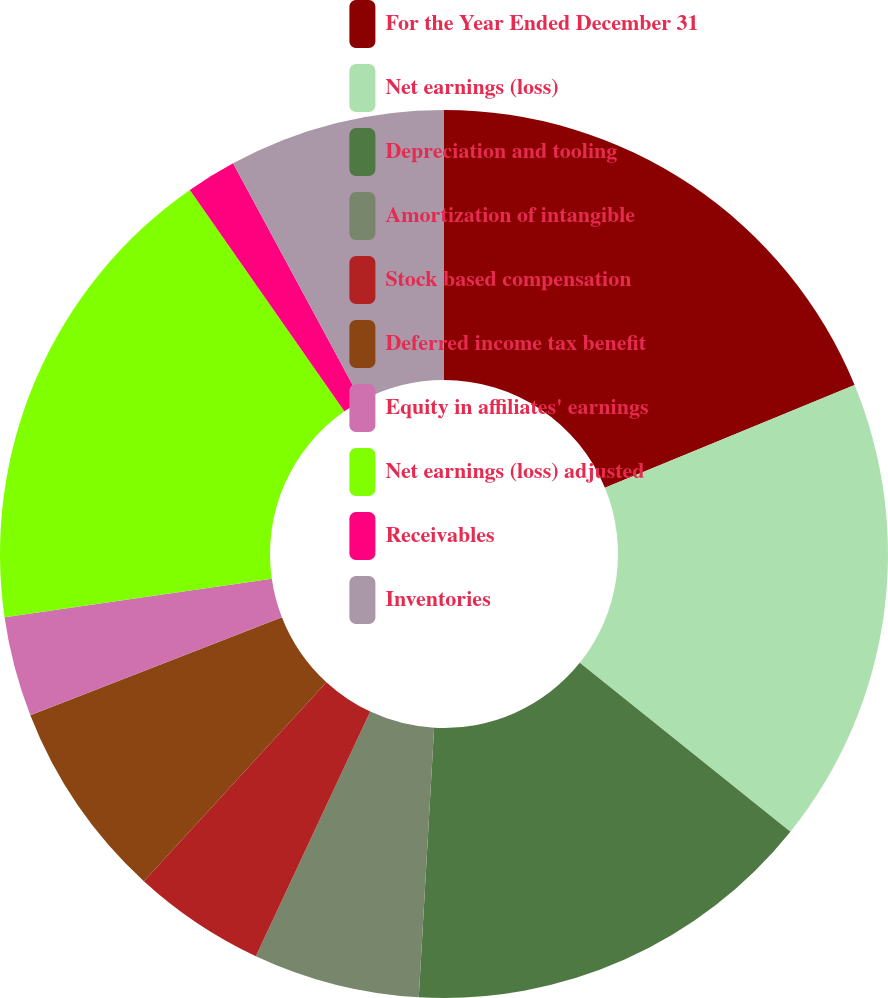Convert chart to OTSL. <chart><loc_0><loc_0><loc_500><loc_500><pie_chart><fcel>For the Year Ended December 31<fcel>Net earnings (loss)<fcel>Depreciation and tooling<fcel>Amortization of intangible<fcel>Stock based compensation<fcel>Deferred income tax benefit<fcel>Equity in affiliates' earnings<fcel>Net earnings (loss) adjusted<fcel>Receivables<fcel>Inventories<nl><fcel>18.79%<fcel>16.97%<fcel>15.15%<fcel>6.06%<fcel>4.85%<fcel>7.27%<fcel>3.64%<fcel>17.58%<fcel>1.82%<fcel>7.88%<nl></chart> 